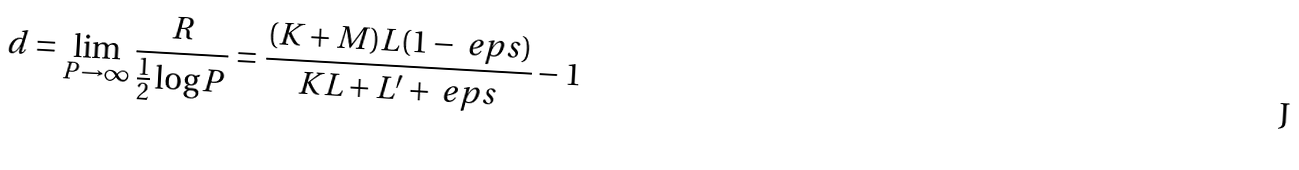Convert formula to latex. <formula><loc_0><loc_0><loc_500><loc_500>d = \lim _ { P \rightarrow \infty } \frac { R } { \frac { 1 } { 2 } \log P } & = \frac { ( K + M ) L ( 1 - \ e p s ) } { K L + L ^ { \prime } + \ e p s } - 1</formula> 